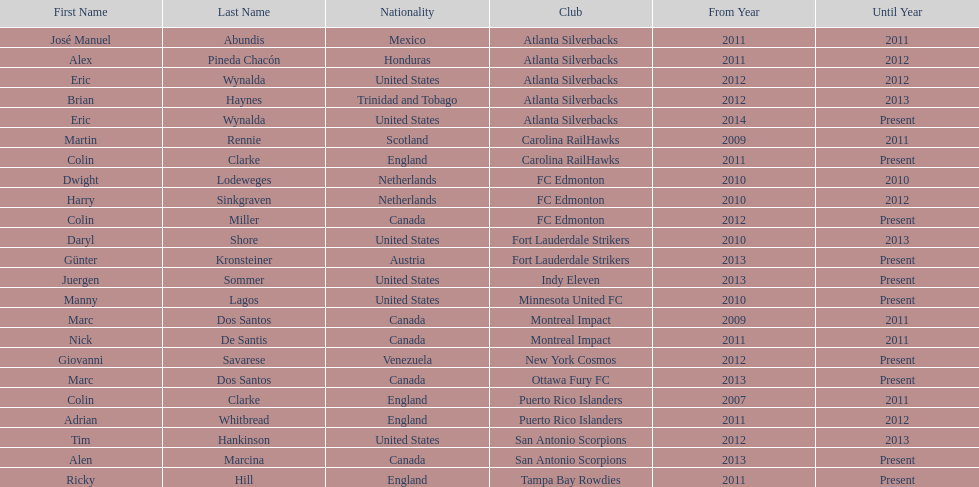Who coached the silverbacks longer, abundis or chacon? Chacon. 